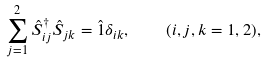<formula> <loc_0><loc_0><loc_500><loc_500>\sum _ { j = 1 } ^ { 2 } \hat { S } ^ { \dag } _ { i j } \hat { S } _ { j k } = \hat { 1 } \delta _ { i k } , \quad ( i , j , k = 1 , 2 ) ,</formula> 